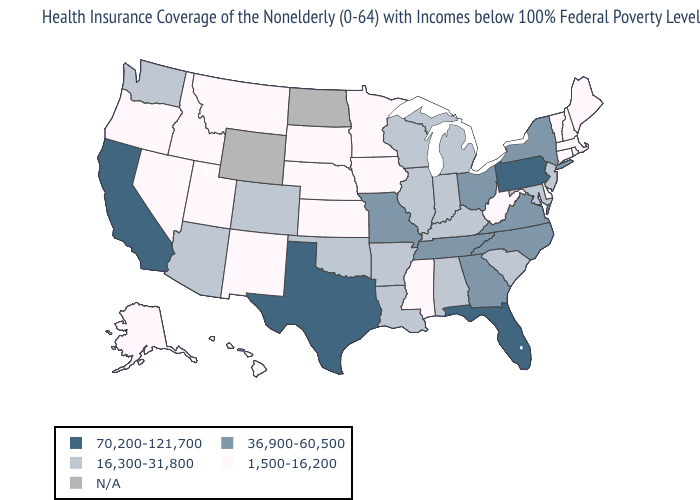What is the value of Florida?
Quick response, please. 70,200-121,700. Does the map have missing data?
Answer briefly. Yes. What is the lowest value in the USA?
Concise answer only. 1,500-16,200. Does the first symbol in the legend represent the smallest category?
Answer briefly. No. Among the states that border Utah , does New Mexico have the lowest value?
Write a very short answer. Yes. Does Illinois have the highest value in the USA?
Concise answer only. No. Which states have the lowest value in the MidWest?
Write a very short answer. Iowa, Kansas, Minnesota, Nebraska, South Dakota. What is the lowest value in the USA?
Quick response, please. 1,500-16,200. Which states have the lowest value in the USA?
Give a very brief answer. Alaska, Connecticut, Delaware, Hawaii, Idaho, Iowa, Kansas, Maine, Massachusetts, Minnesota, Mississippi, Montana, Nebraska, Nevada, New Hampshire, New Mexico, Oregon, Rhode Island, South Dakota, Utah, Vermont, West Virginia. What is the value of California?
Quick response, please. 70,200-121,700. What is the value of Alabama?
Concise answer only. 16,300-31,800. Is the legend a continuous bar?
Short answer required. No. What is the lowest value in the USA?
Answer briefly. 1,500-16,200. Does the first symbol in the legend represent the smallest category?
Keep it brief. No. 